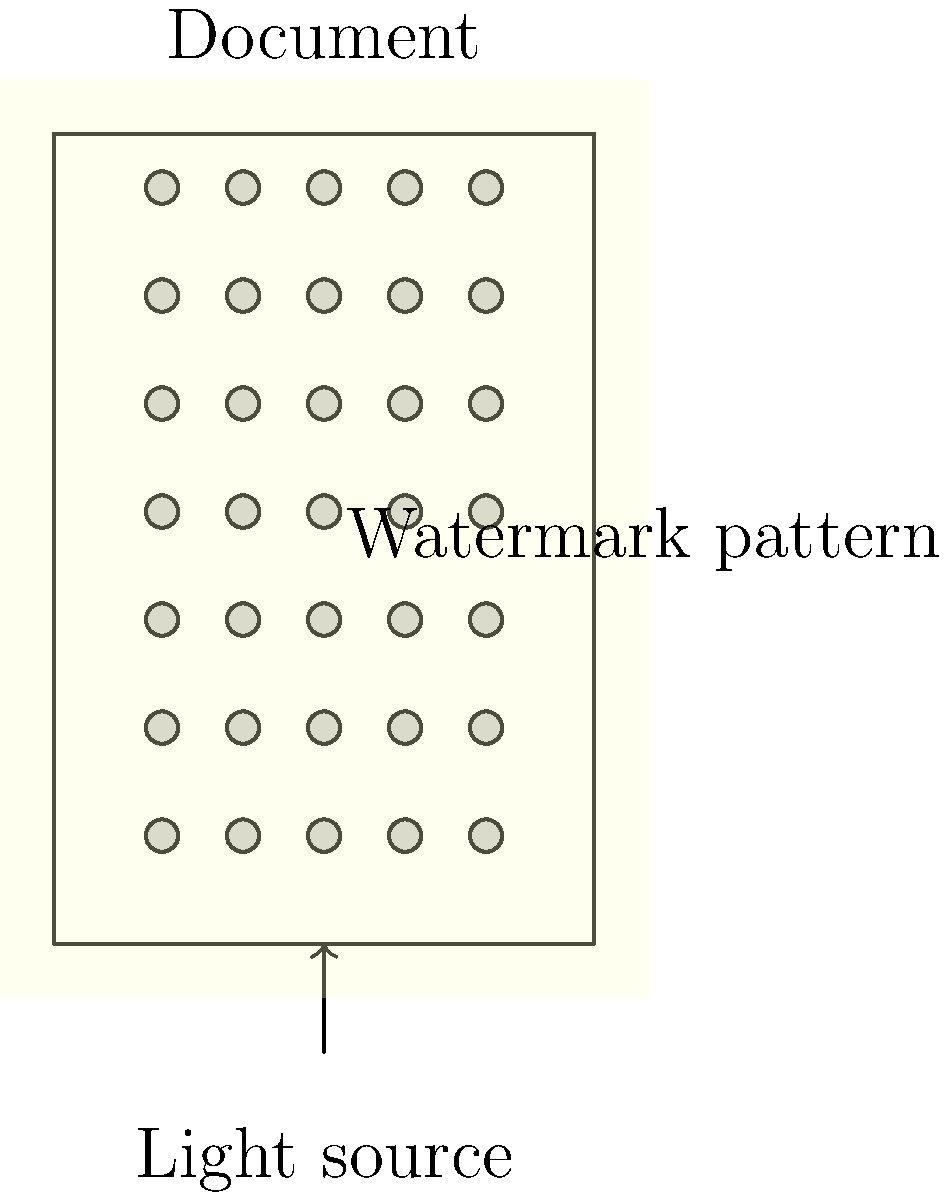When verifying the authenticity of a watermark using transmitted light, what pattern should be observed in the diagram, and how does this relate to the document's legitimacy? To verify the authenticity of a watermark using transmitted light, follow these steps:

1. Position the document: Place the document on a flat surface with a light source beneath it.

2. Observe the transmitted light pattern: In the diagram, we can see a regular grid pattern of circular shapes when light is transmitted through the document.

3. Analyze the pattern:
   a. Regularity: The watermark pattern should be consistent and evenly spaced.
   b. Clarity: The circular shapes should be clearly visible and well-defined.
   c. Alignment: The pattern should align with the document's orientation.

4. Compare with known genuine documents: The observed pattern should match the expected watermark design for that particular type of document.

5. Check for inconsistencies: Any irregularities in the pattern, such as missing or distorted elements, may indicate a forged document.

6. Evaluate overall quality: Authentic watermarks typically have a high level of detail and precision that is difficult to replicate.

7. Consider additional security features: While the watermark is important, it should be evaluated in conjunction with other security elements present in the document.

The legitimacy of the document is supported if the observed watermark pattern matches the expected design, shows consistency, and exhibits high quality. Any deviations from the expected pattern or quality may indicate potential forgery or tampering.
Answer: Regular grid of circular shapes matching the expected design 